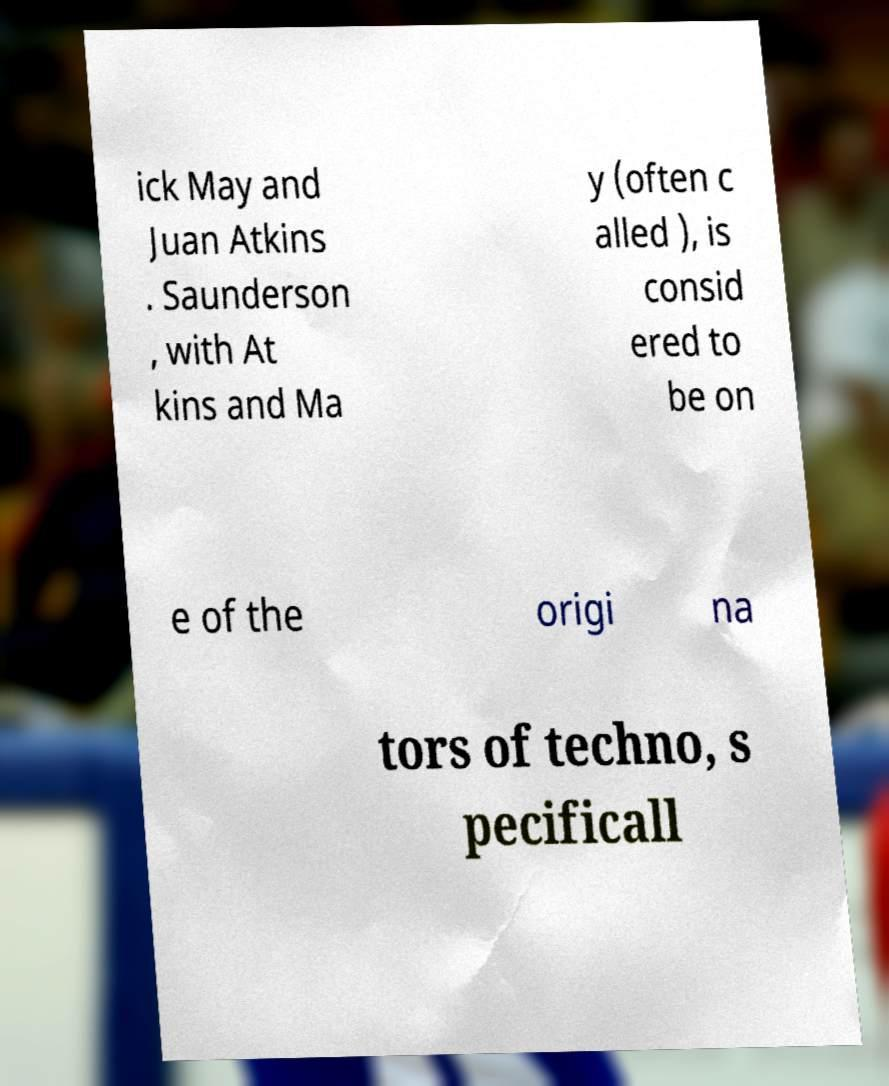Could you extract and type out the text from this image? ick May and Juan Atkins . Saunderson , with At kins and Ma y (often c alled ), is consid ered to be on e of the origi na tors of techno, s pecificall 